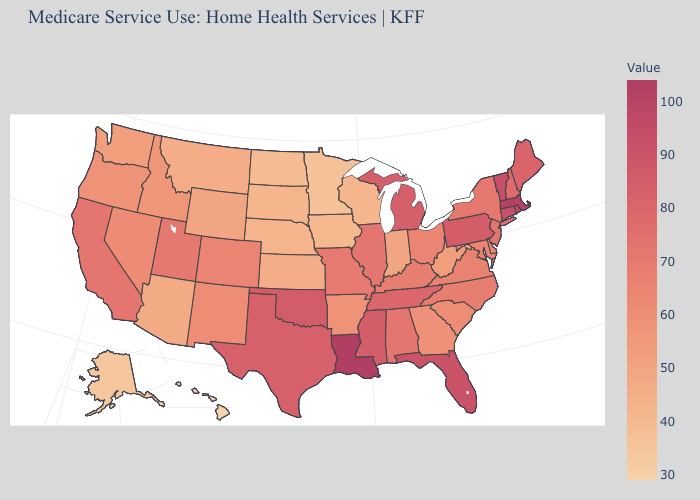Is the legend a continuous bar?
Concise answer only. Yes. Which states have the highest value in the USA?
Write a very short answer. Louisiana. Does Washington have the highest value in the West?
Concise answer only. No. Does Hawaii have the lowest value in the West?
Write a very short answer. Yes. Among the states that border Kansas , which have the highest value?
Short answer required. Oklahoma. Among the states that border North Carolina , which have the highest value?
Short answer required. Tennessee. Among the states that border Missouri , which have the highest value?
Quick response, please. Oklahoma. 